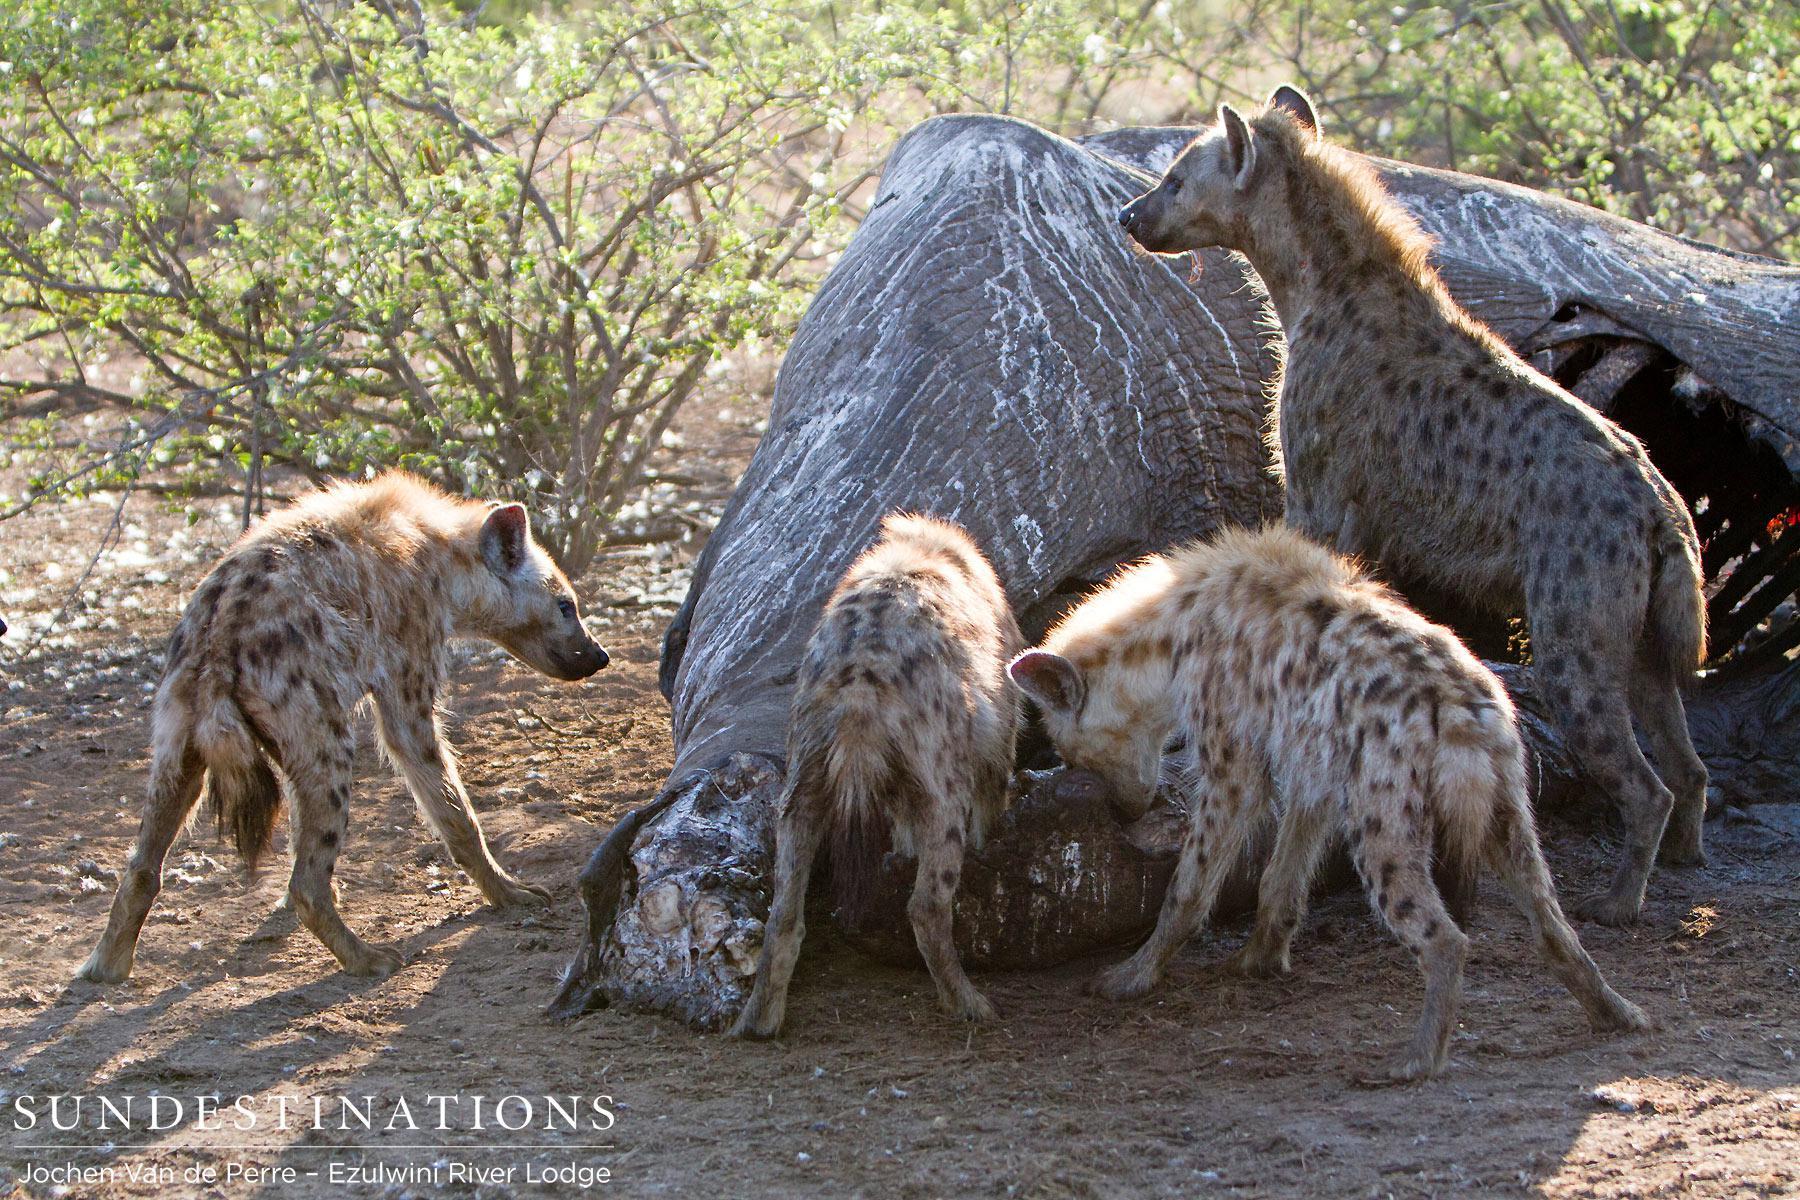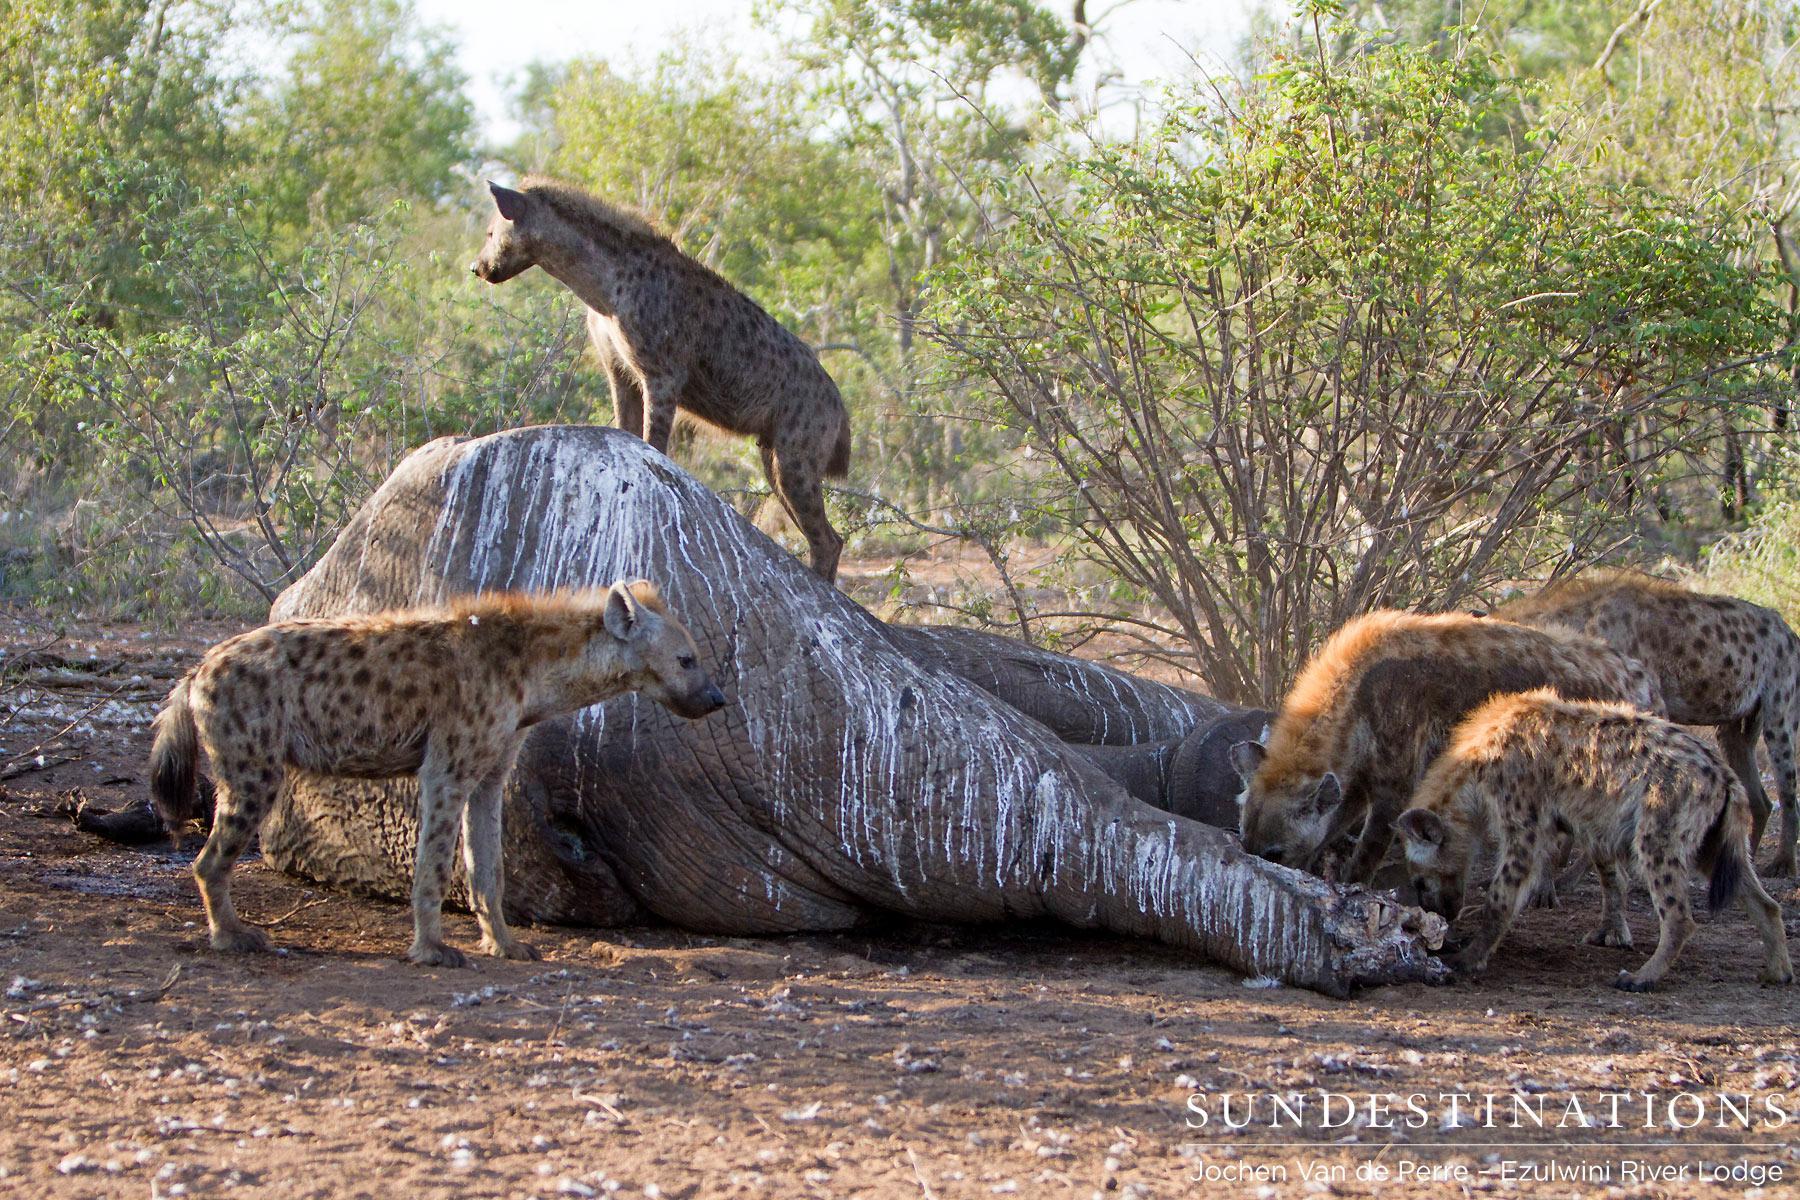The first image is the image on the left, the second image is the image on the right. For the images displayed, is the sentence "The right image contains exactly one hyena." factually correct? Answer yes or no. No. The first image is the image on the left, the second image is the image on the right. Examine the images to the left and right. Is the description "There is at least one hyena in the left image." accurate? Answer yes or no. Yes. 